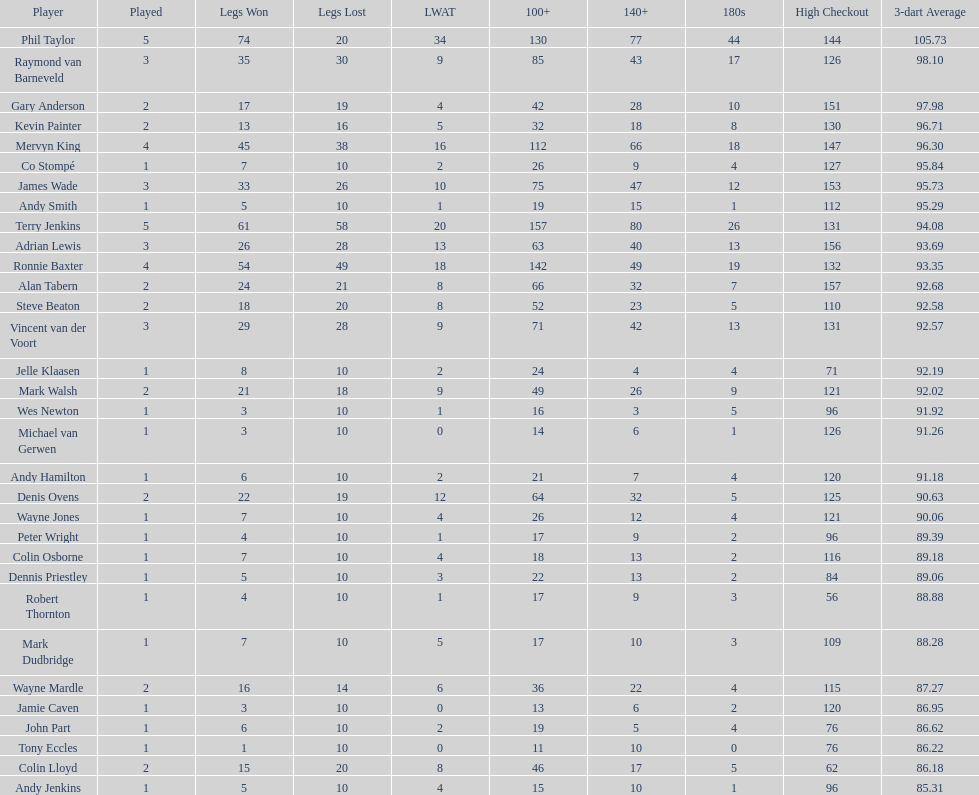In the 2009 world matchplay, how many competitors achieved at least 30 legs? 6. 